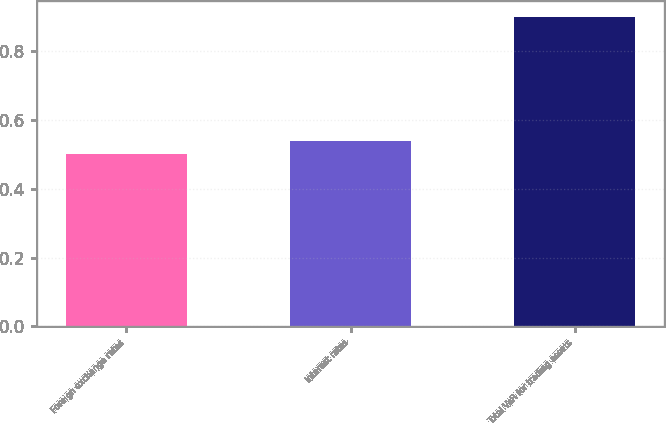Convert chart to OTSL. <chart><loc_0><loc_0><loc_500><loc_500><bar_chart><fcel>Foreign exchange rates<fcel>Interest rates<fcel>Total VaR for trading assets<nl><fcel>0.5<fcel>0.54<fcel>0.9<nl></chart> 